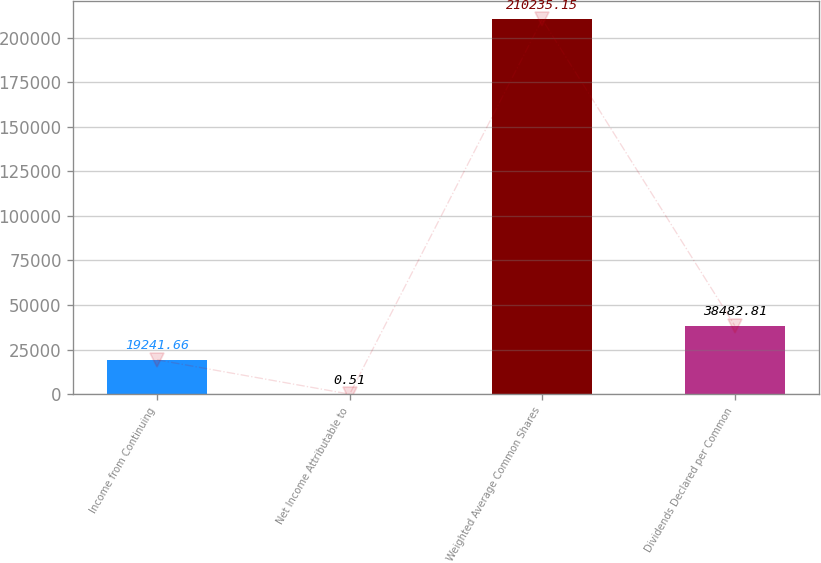Convert chart. <chart><loc_0><loc_0><loc_500><loc_500><bar_chart><fcel>Income from Continuing<fcel>Net Income Attributable to<fcel>Weighted Average Common Shares<fcel>Dividends Declared per Common<nl><fcel>19241.7<fcel>0.51<fcel>210235<fcel>38482.8<nl></chart> 